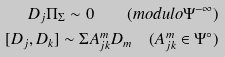<formula> <loc_0><loc_0><loc_500><loc_500>D _ { j } \Pi _ { \Sigma } \sim 0 \quad ( m o d u l o \Psi ^ { - \infty } ) \\ [ D _ { j } , D _ { k } ] \sim \Sigma A ^ { m } _ { j k } D _ { m } \quad ( A ^ { m } _ { j k } \in \Psi ^ { \circ } )</formula> 